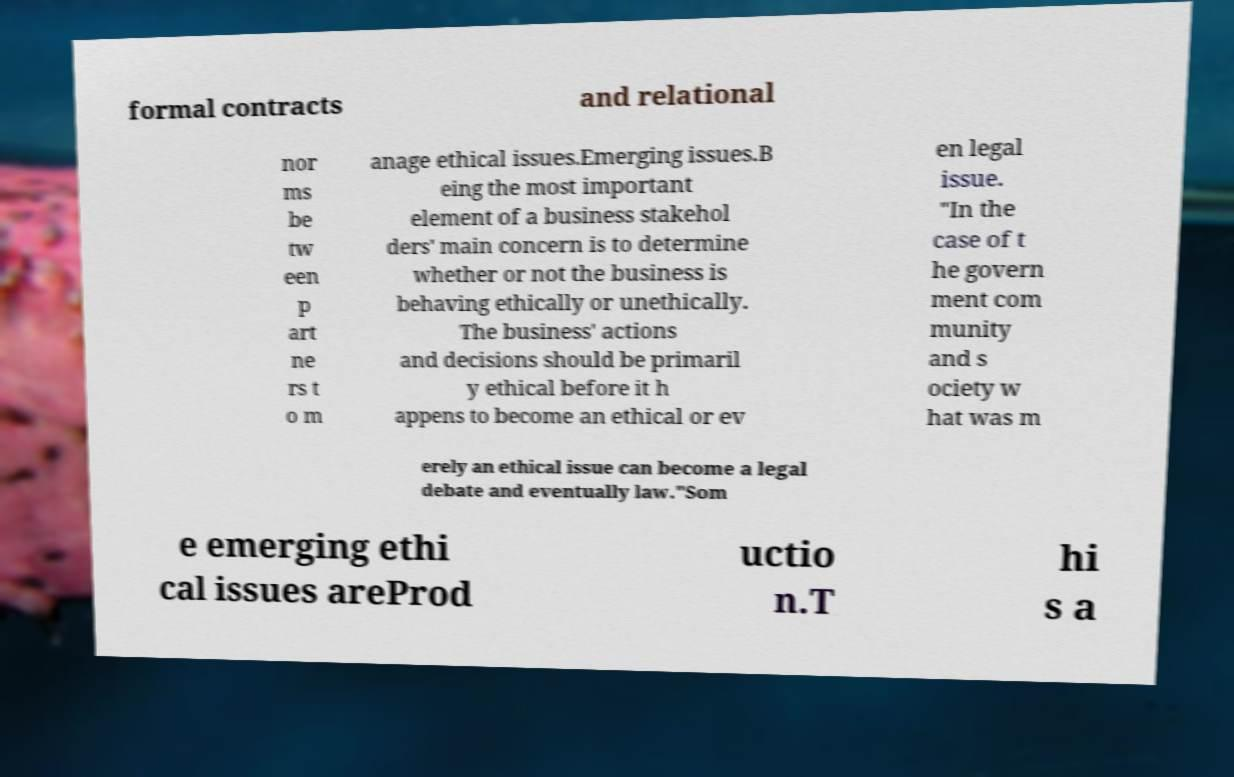Can you accurately transcribe the text from the provided image for me? formal contracts and relational nor ms be tw een p art ne rs t o m anage ethical issues.Emerging issues.B eing the most important element of a business stakehol ders' main concern is to determine whether or not the business is behaving ethically or unethically. The business' actions and decisions should be primaril y ethical before it h appens to become an ethical or ev en legal issue. "In the case of t he govern ment com munity and s ociety w hat was m erely an ethical issue can become a legal debate and eventually law."Som e emerging ethi cal issues areProd uctio n.T hi s a 